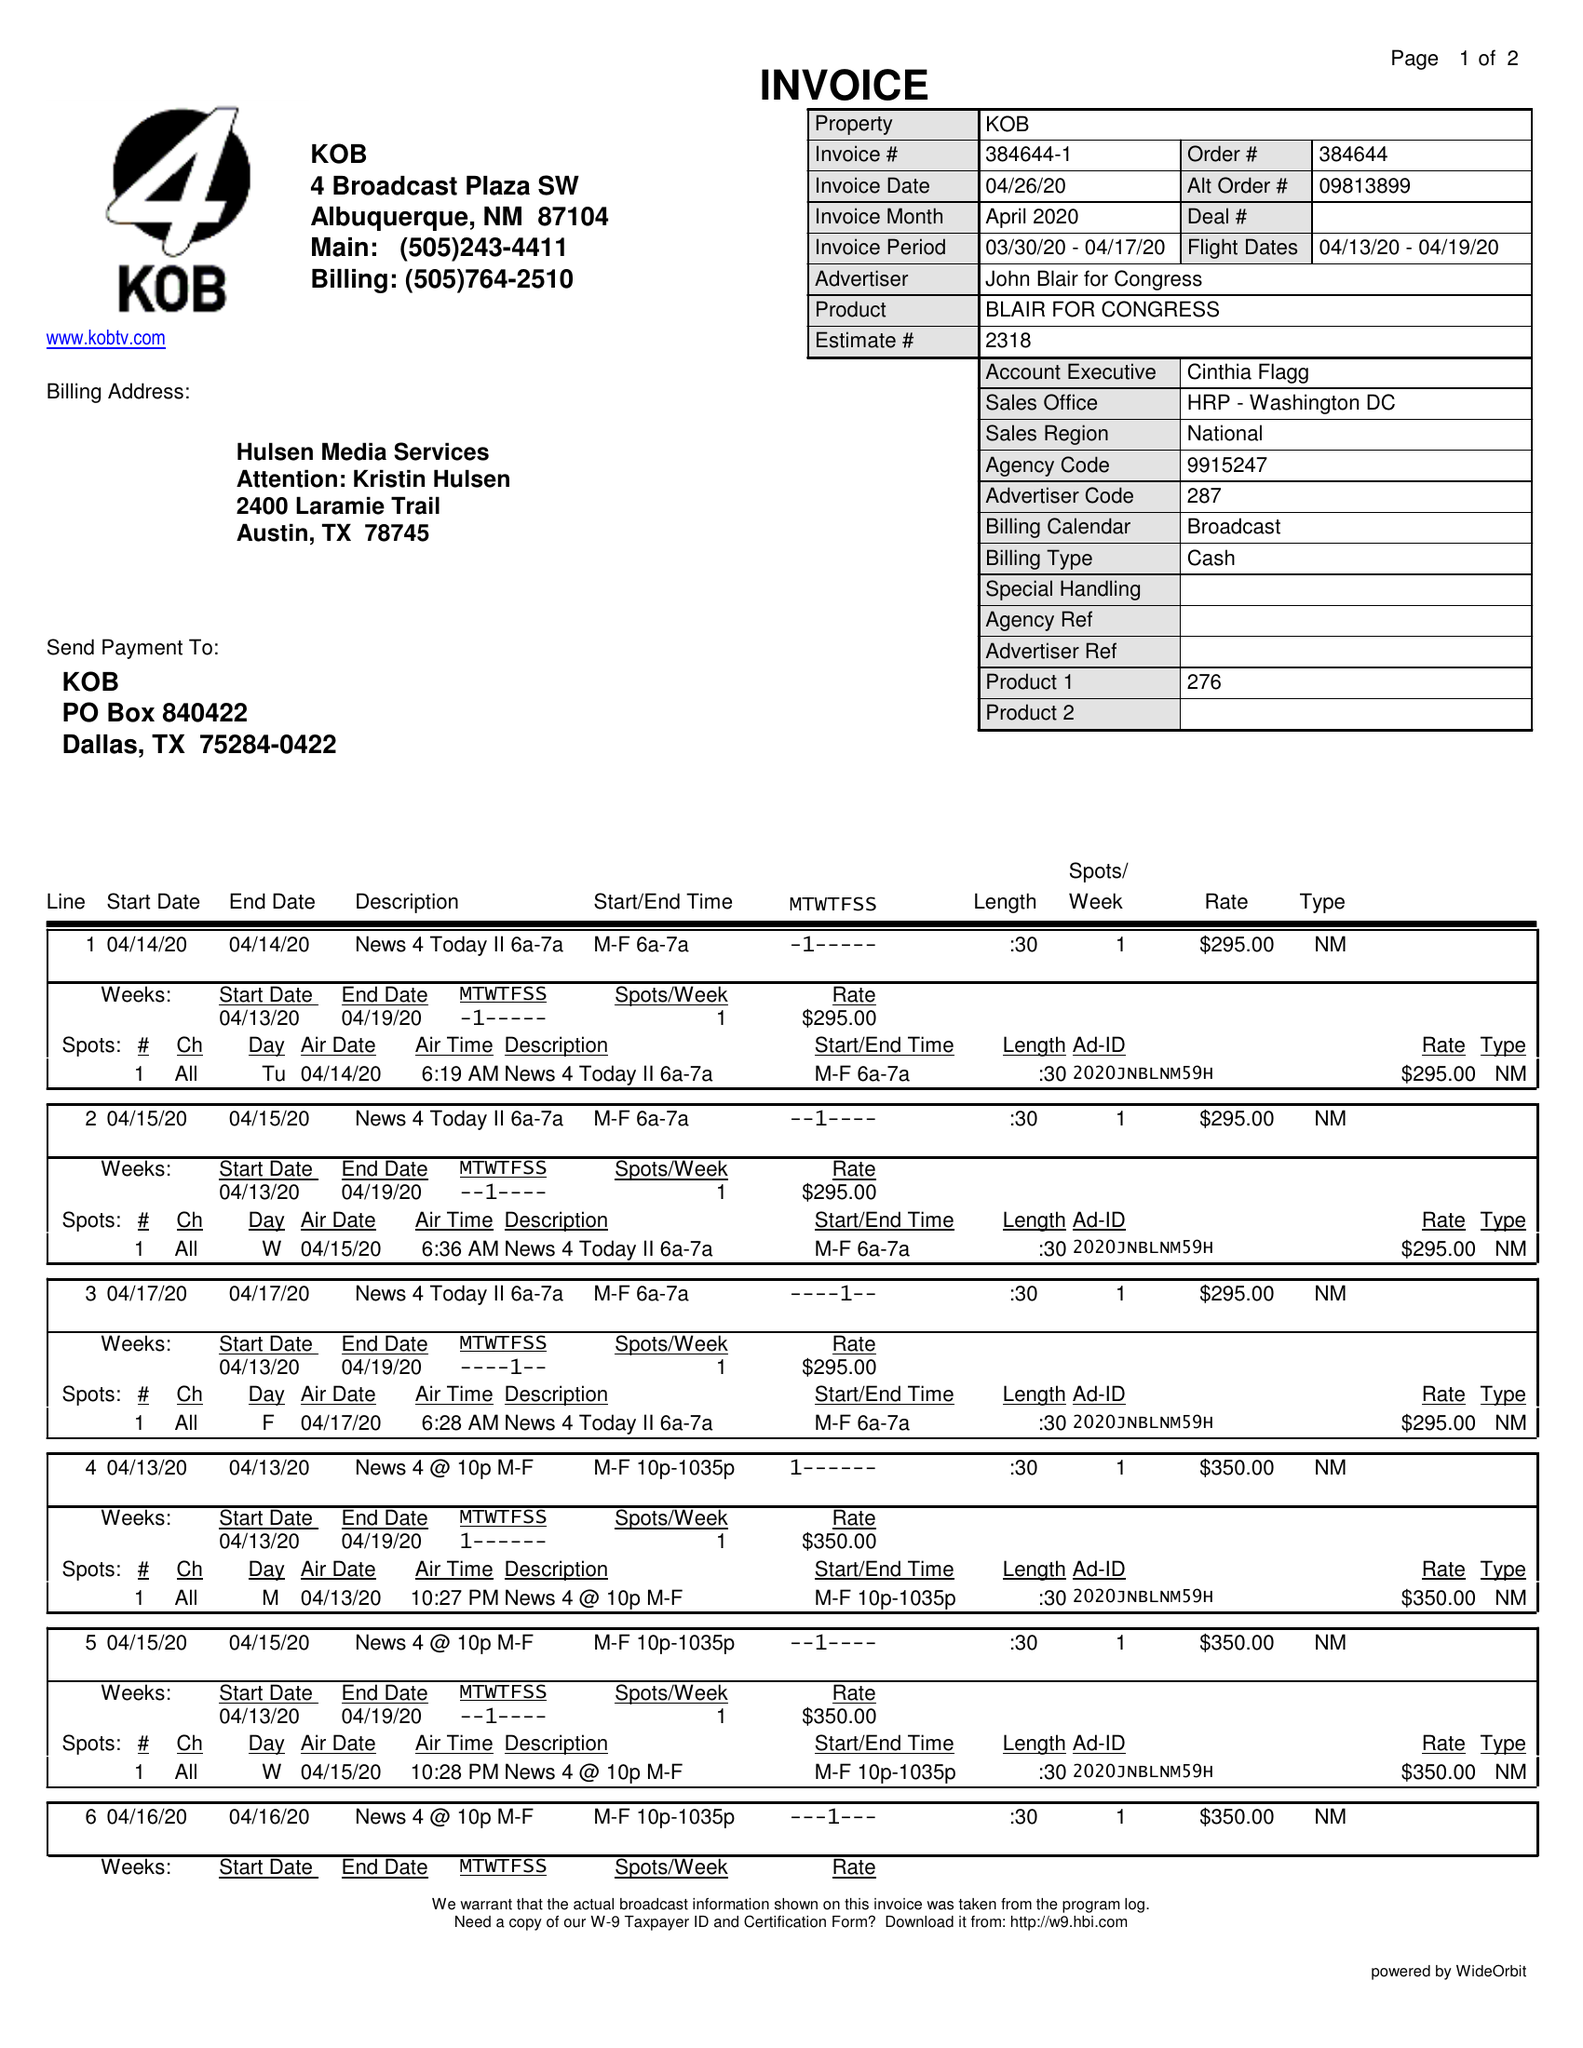What is the value for the flight_to?
Answer the question using a single word or phrase. 04/19/20 